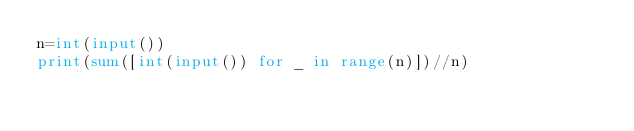<code> <loc_0><loc_0><loc_500><loc_500><_Python_>n=int(input())
print(sum([int(input()) for _ in range(n)])//n)</code> 